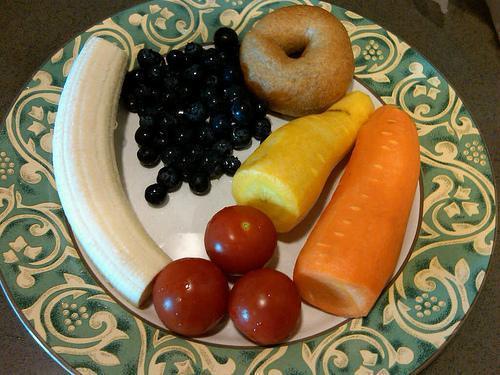How many carrots are there?
Give a very brief answer. 2. How many fences shown in this picture are between the giraffe and the camera?
Give a very brief answer. 0. 